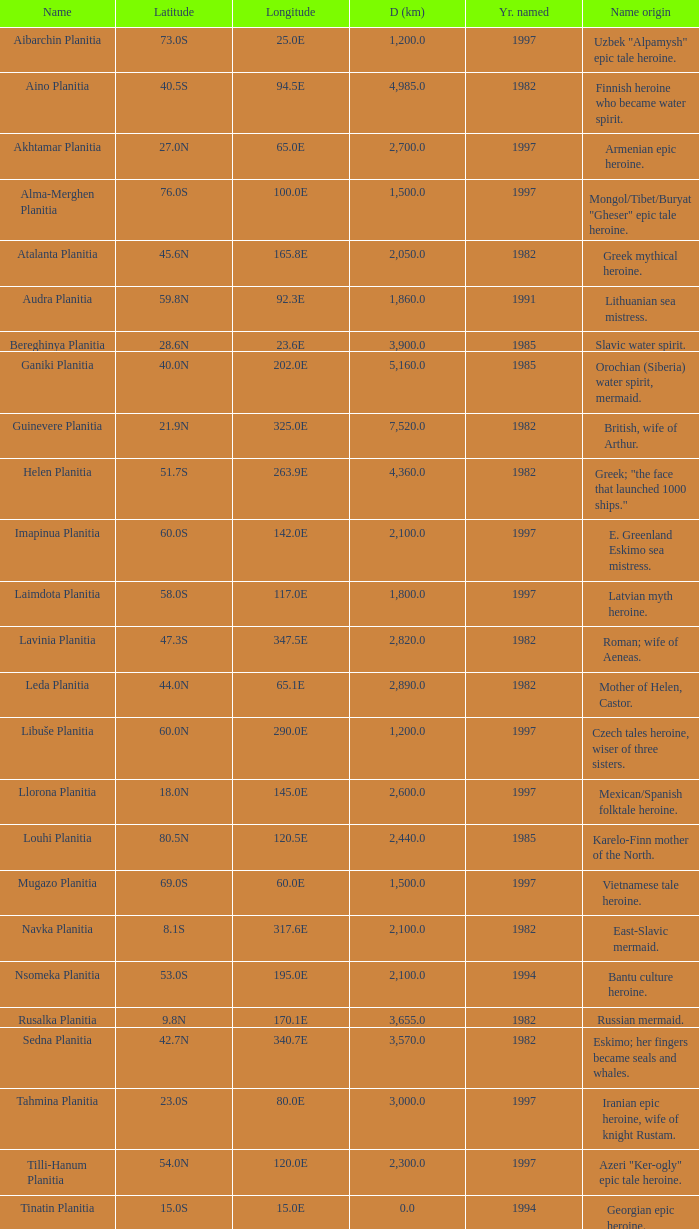What's the name origin of feature of diameter (km) 2,155.0 Karelo-Finn mermaid. 